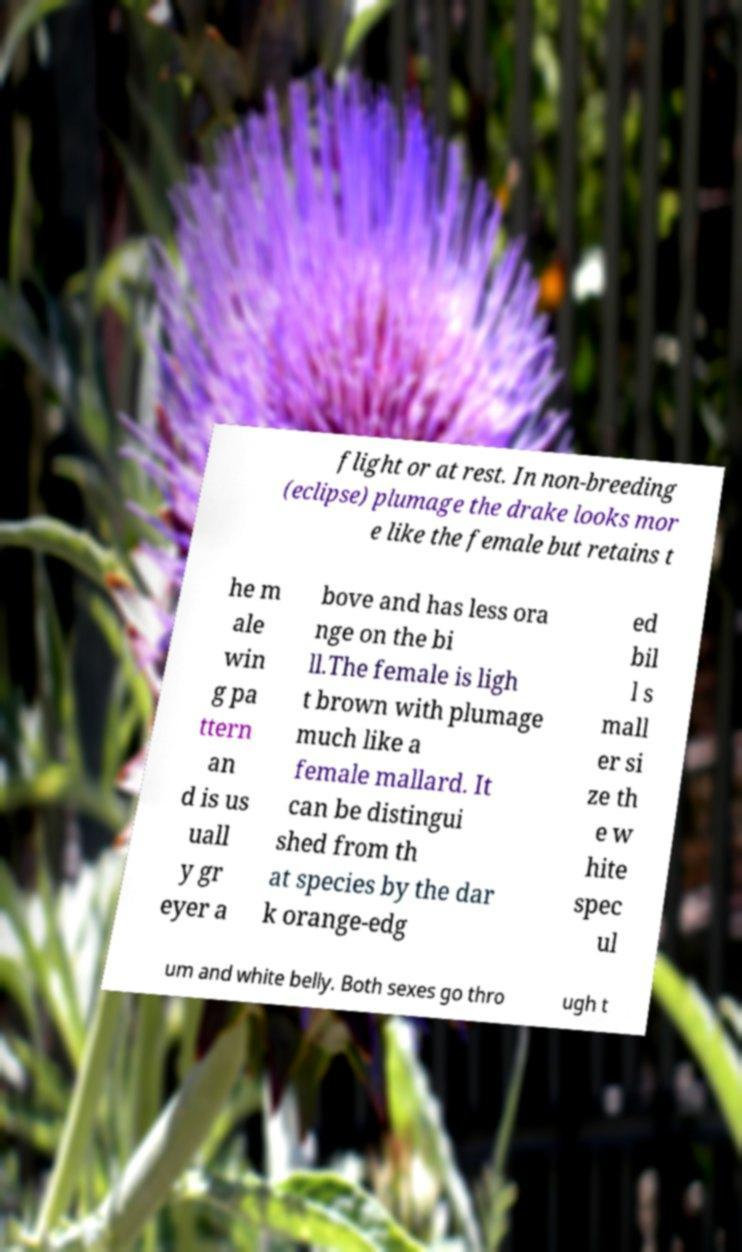I need the written content from this picture converted into text. Can you do that? flight or at rest. In non-breeding (eclipse) plumage the drake looks mor e like the female but retains t he m ale win g pa ttern an d is us uall y gr eyer a bove and has less ora nge on the bi ll.The female is ligh t brown with plumage much like a female mallard. It can be distingui shed from th at species by the dar k orange-edg ed bil l s mall er si ze th e w hite spec ul um and white belly. Both sexes go thro ugh t 